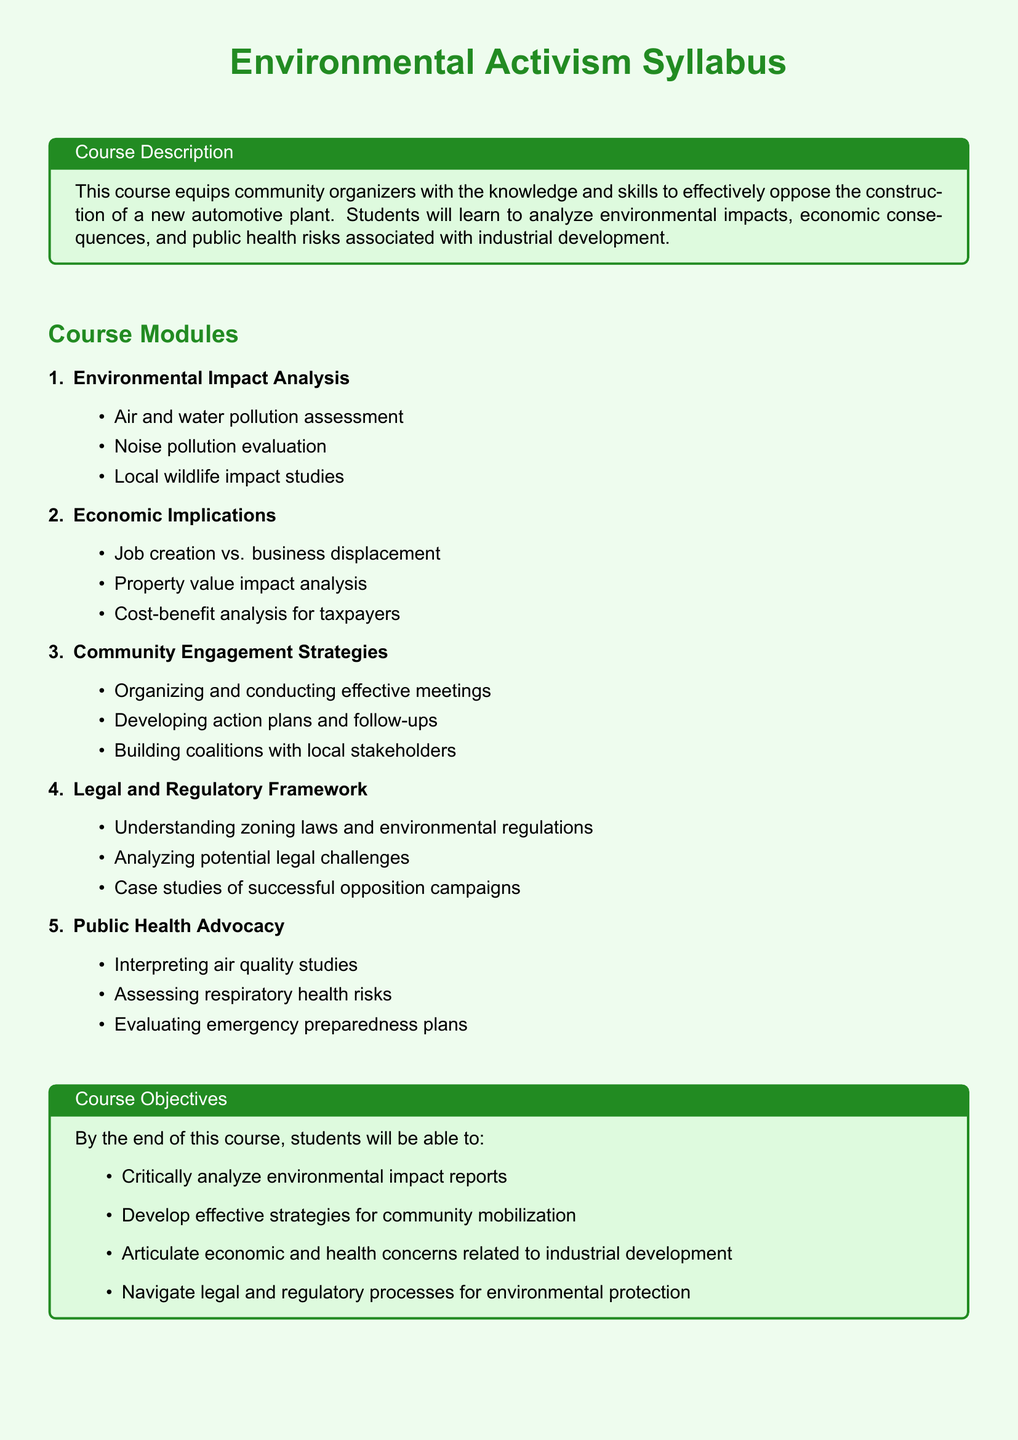What is the first course module? The first course module is titled "Environmental Impact Analysis" and contains various topics related to environmental assessments.
Answer: Environmental Impact Analysis How much percentage of the assessment does the group project account for? The syllabus specifies that the group project accounts for 40 percent of the overall assessment.
Answer: 40% What are the proposed discussion points included in the community meeting agendas? The document mentions that the community meeting agendas include proposed discussion points but does not provide specifics.
Answer: Not specified What is the key focus of the Public Health Advocacy module? The key focus of this module is on interpreting air quality studies and assessing health risks related to respiratory issues.
Answer: Interpreting air quality studies and assessing respiratory health risks What type of analysis is included in the Economic Implications module? The Economic Implications module includes cost-benefit analysis for taxpayers.
Answer: Cost-benefit analysis for taxpayers 